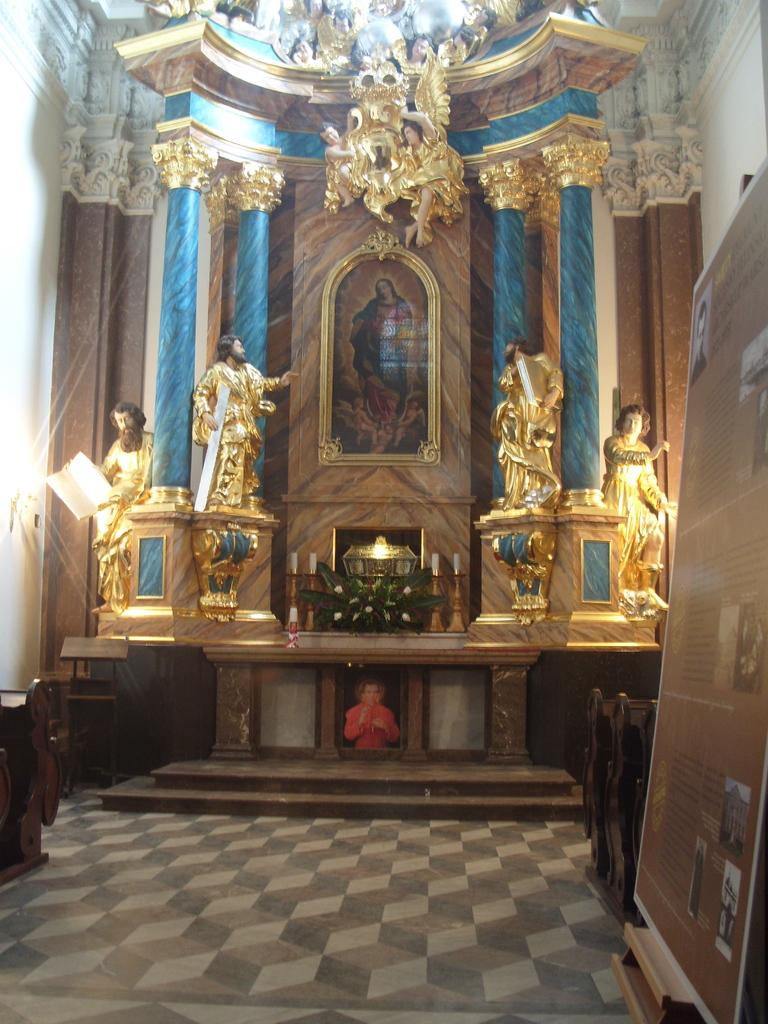What type of structure is present in the image? There is a building in the image. What additional features can be seen near the building? There are statues in the image. Can you describe any specific details about the building? There is a board on the side of the building in the image. What type of cannon is being fired by the beast in the image? There is no cannon or beast present in the image. How is the yoke being used in the image? There is no yoke present in the image. 